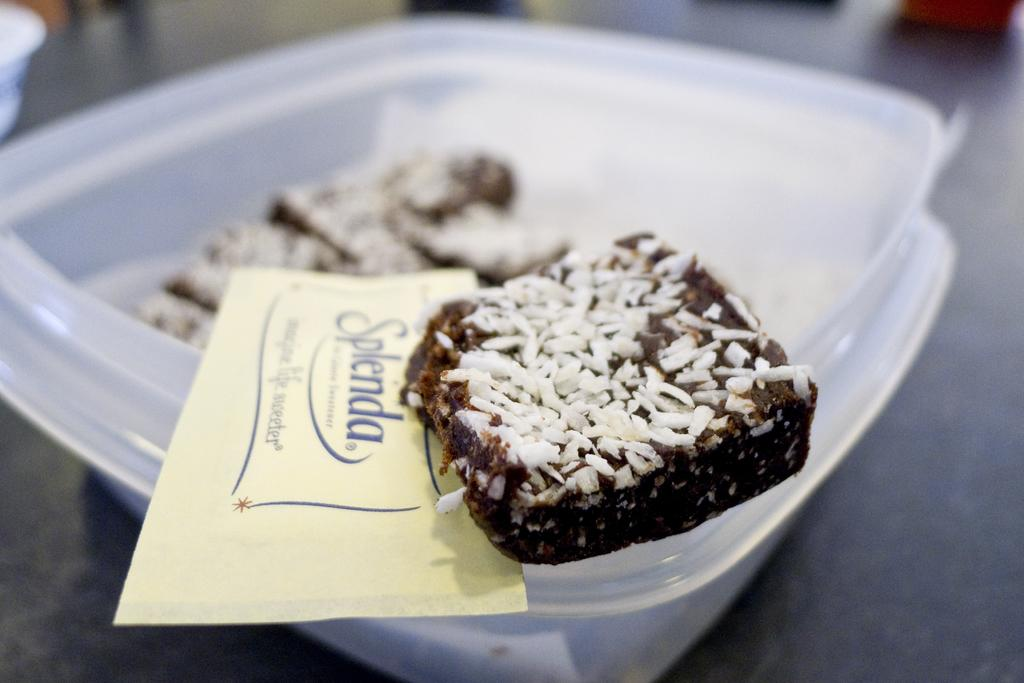What is the color of the box in the image? The box in the image is white. What is inside the box? There are sweets in the box. Is there any additional item in the box besides the sweets? Yes, there is a card with text written on it in the box. What type of company is depicted in the picture inside the box? There is no picture inside the box, only a card with text written on it. 